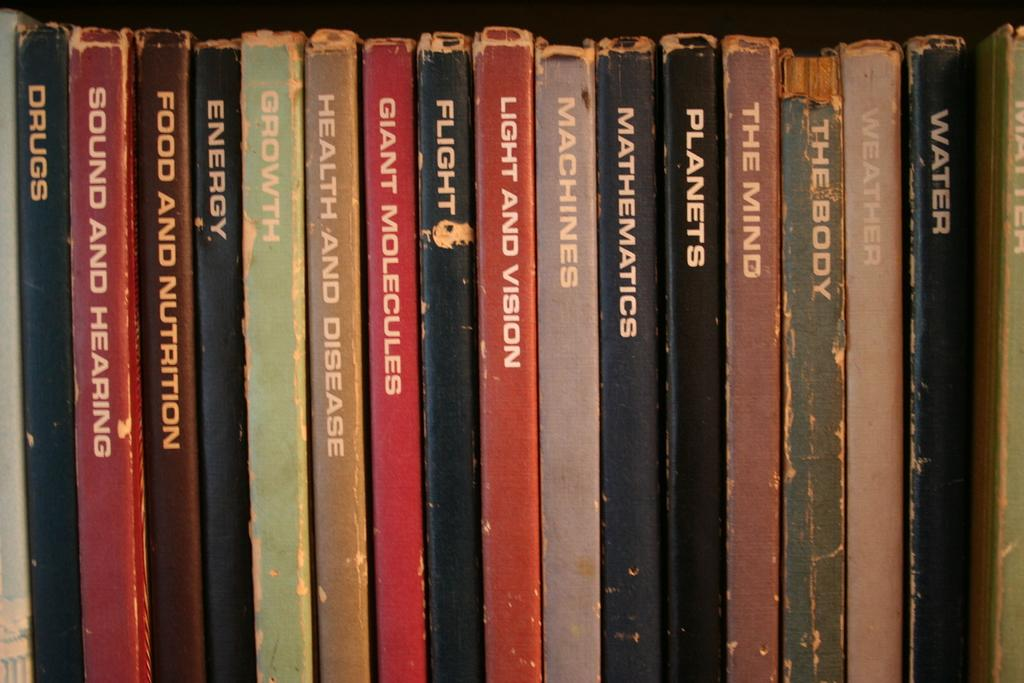What type of objects can be seen in the image? There are books in the image. Can you describe the books in more detail? Unfortunately, the image does not provide enough detail to describe the books further. How many letters are written on the quartz in the image? There is no quartz or letters present in the image; it only contains books. 